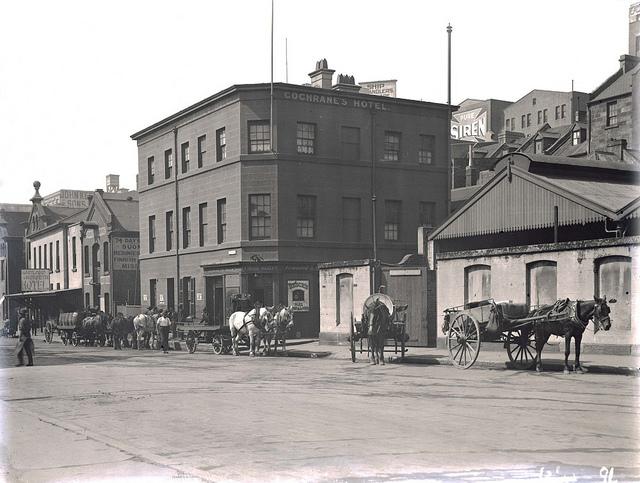Does this look like the olden days?
Answer briefly. Yes. Is this a country road?
Keep it brief. No. What century was this picture taken in?
Short answer required. 19th. Is that a bus stop near the bus?
Concise answer only. No. How many horses?
Concise answer only. 6. Is there are car in the middle of the road?
Keep it brief. No. How many people are there?
Quick response, please. 2. What is the horse pulling?
Keep it brief. Carriage. 